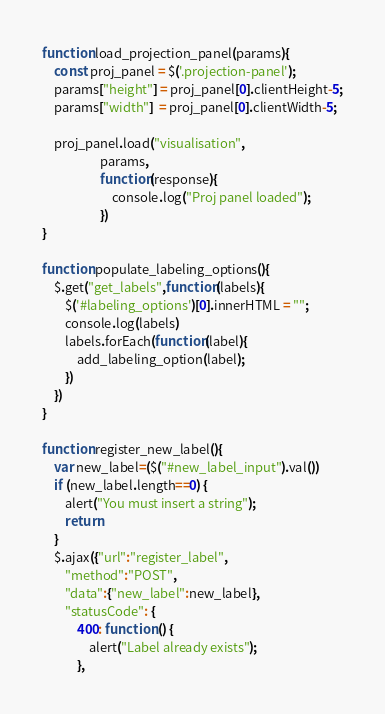Convert code to text. <code><loc_0><loc_0><loc_500><loc_500><_JavaScript_>function load_projection_panel(params){
    const proj_panel = $('.projection-panel');
    params["height"] = proj_panel[0].clientHeight-5;
    params["width"]  = proj_panel[0].clientWidth-5;

    proj_panel.load("visualisation",
                    params,
                    function(response){
                        console.log("Proj panel loaded");
                    })
}

function populate_labeling_options(){
    $.get("get_labels",function(labels){
        $('#labeling_options')[0].innerHTML = "";
        console.log(labels)
        labels.forEach(function(label){
            add_labeling_option(label);
        })
    })
}

function register_new_label(){
    var new_label=($("#new_label_input").val())
    if (new_label.length==0) {
        alert("You must insert a string");
        return
    }
    $.ajax({"url":"register_label",
        "method":"POST",
        "data":{"new_label":new_label},
        "statusCode": {
            400: function () {
                alert("Label already exists");
            },</code> 